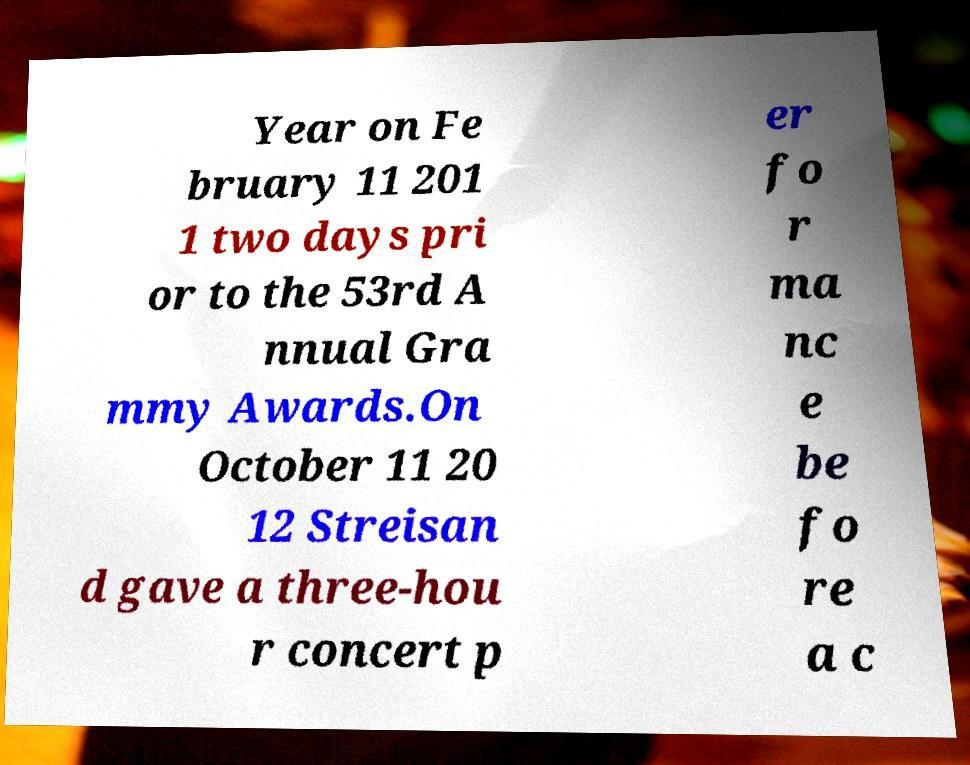What messages or text are displayed in this image? I need them in a readable, typed format. Year on Fe bruary 11 201 1 two days pri or to the 53rd A nnual Gra mmy Awards.On October 11 20 12 Streisan d gave a three-hou r concert p er fo r ma nc e be fo re a c 